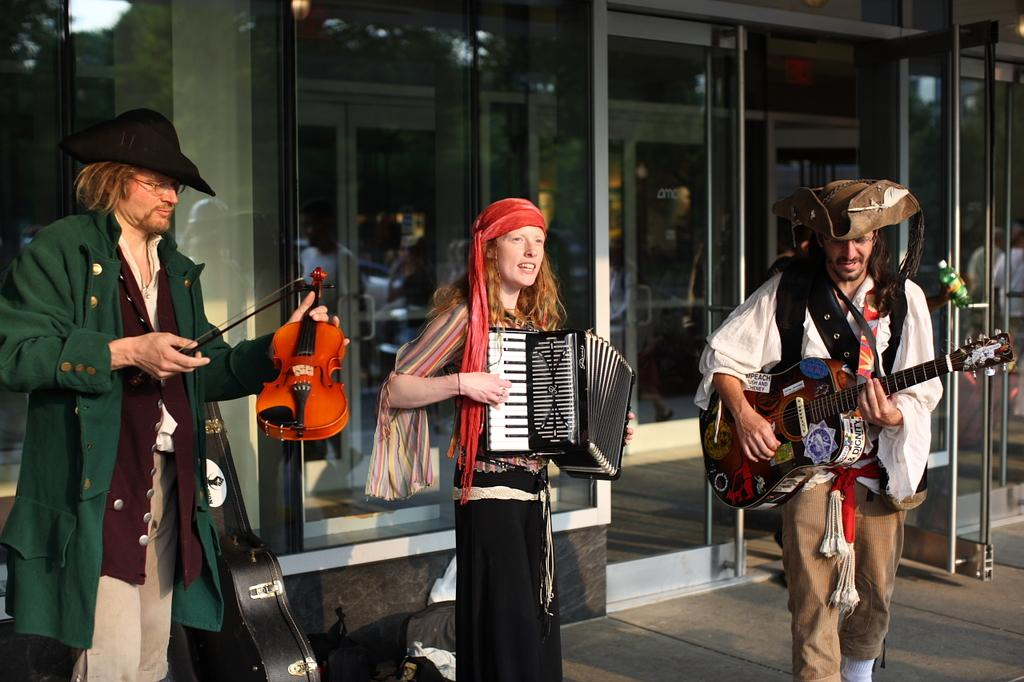How many people are present in the image? There are three individuals in the image, including two men and a woman. What are the people in the image doing? All three individuals are holding musical instruments. What type of butter is being used to play the musical instruments in the image? There is no butter present in the image, and it is not being used to play the musical instruments. 